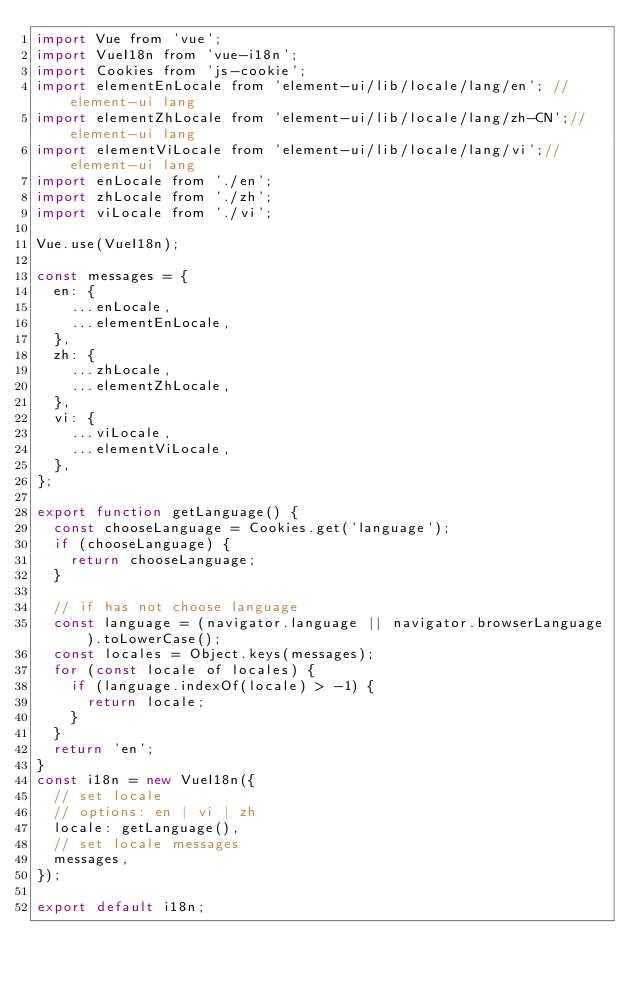Convert code to text. <code><loc_0><loc_0><loc_500><loc_500><_JavaScript_>import Vue from 'vue';
import VueI18n from 'vue-i18n';
import Cookies from 'js-cookie';
import elementEnLocale from 'element-ui/lib/locale/lang/en'; // element-ui lang
import elementZhLocale from 'element-ui/lib/locale/lang/zh-CN';// element-ui lang
import elementViLocale from 'element-ui/lib/locale/lang/vi';// element-ui lang
import enLocale from './en';
import zhLocale from './zh';
import viLocale from './vi';

Vue.use(VueI18n);

const messages = {
  en: {
    ...enLocale,
    ...elementEnLocale,
  },
  zh: {
    ...zhLocale,
    ...elementZhLocale,
  },
  vi: {
    ...viLocale,
    ...elementViLocale,
  },
};

export function getLanguage() {
  const chooseLanguage = Cookies.get('language');
  if (chooseLanguage) {
    return chooseLanguage;
  }

  // if has not choose language
  const language = (navigator.language || navigator.browserLanguage).toLowerCase();
  const locales = Object.keys(messages);
  for (const locale of locales) {
    if (language.indexOf(locale) > -1) {
      return locale;
    }
  }
  return 'en';
}
const i18n = new VueI18n({
  // set locale
  // options: en | vi | zh
  locale: getLanguage(),
  // set locale messages
  messages,
});

export default i18n;
</code> 